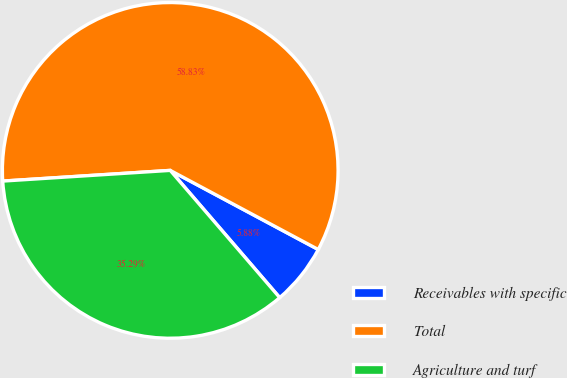Convert chart to OTSL. <chart><loc_0><loc_0><loc_500><loc_500><pie_chart><fcel>Receivables with specific<fcel>Total<fcel>Agriculture and turf<nl><fcel>5.88%<fcel>58.82%<fcel>35.29%<nl></chart> 